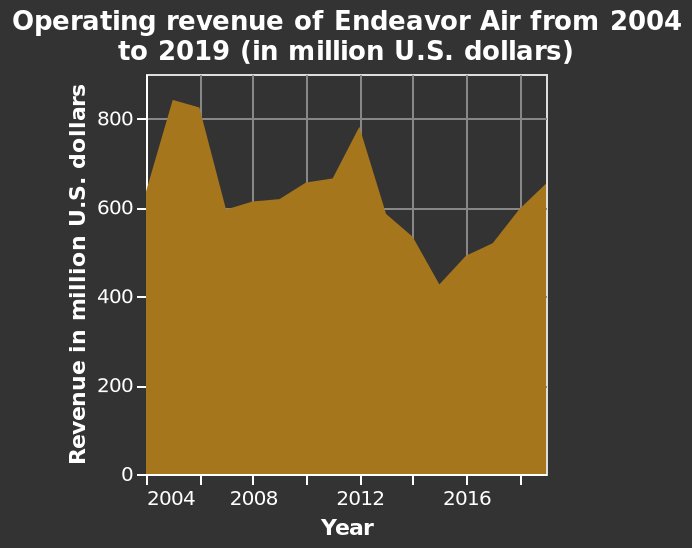<image>
What is the overall trend of revenue for Endeavor Air according to the area chart?  The overall trend of revenue for Endeavor Air is a downward trend. What is being measured on the y-axis of the graph?  The y-axis measures the operating revenue of Endeavor Air in million U.S. dollars. 